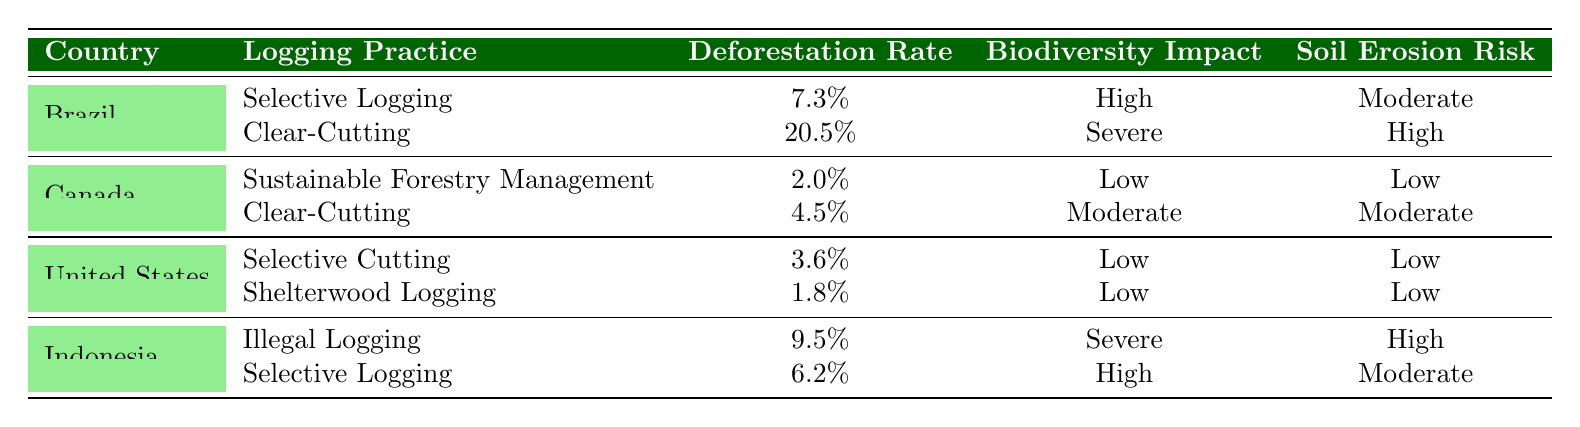What is the deforestation rate for Clear-Cutting in Brazil? According to the table, the deforestation rate for Clear-Cutting in Brazil is specifically stated under Brazil's logging practices. Clear-Cutting shows a deforestation rate of 20.5%.
Answer: 20.5% Which logging practice in Canada has the highest biodiversity impact? In Canada, the two logging practices listed are Sustainable Forestry Management and Clear-Cutting. The biodiversity impacts are Low and Moderate respectively. Hence, Clear-Cutting has the highest biodiversity impact among them.
Answer: Clear-Cutting True or False: The soil erosion risk for Sustainable Forestry Management in Canada is High. The table states that the soil erosion risk for Sustainable Forestry Management in Canada is Low. Thus, the statement is false.
Answer: False What is the difference in deforestation rates between Clear-Cutting in Brazil and Clear-Cutting in Canada? Clear-Cutting in Brazil has a deforestation rate of 20.5%, while in Canada, it is 4.5%. To find the difference, subtract Canada's rate from Brazil's: 20.5% - 4.5% = 16%.
Answer: 16% Which country's logging practices exhibit the least risk of soil erosion overall? By examining the table, United States practices show Selective Cutting and Shelterwood Logging, both with Low soil erosion risk. In contrast, other countries have either Moderate or High risks, indicating the United States has the least risk overall.
Answer: United States What is the average deforestation rate for the logging practices in Indonesia? In Indonesia, the logging practices of Illegal Logging and Selective Logging have deforestation rates of 9.5% and 6.2% respectively. To find the average: (9.5% + 6.2%) / 2 = 7.85%.
Answer: 7.85% True or False: Selective Logging in Brazil has a higher deforestation rate than Sustainable Forestry Management in Canada. The deforestation rate for Selective Logging in Brazil is 7.3%, while Sustainable Forestry Management in Canada is 2.0%. Since 7.3% is greater than 2.0%, the statement is true.
Answer: True What is the biodiversity impact of Selective Logging in Indonesia? The table specifies that Selective Logging in Indonesia has a biodiversity impact of High, which is clearly noted in the impact section for that practice.
Answer: High 